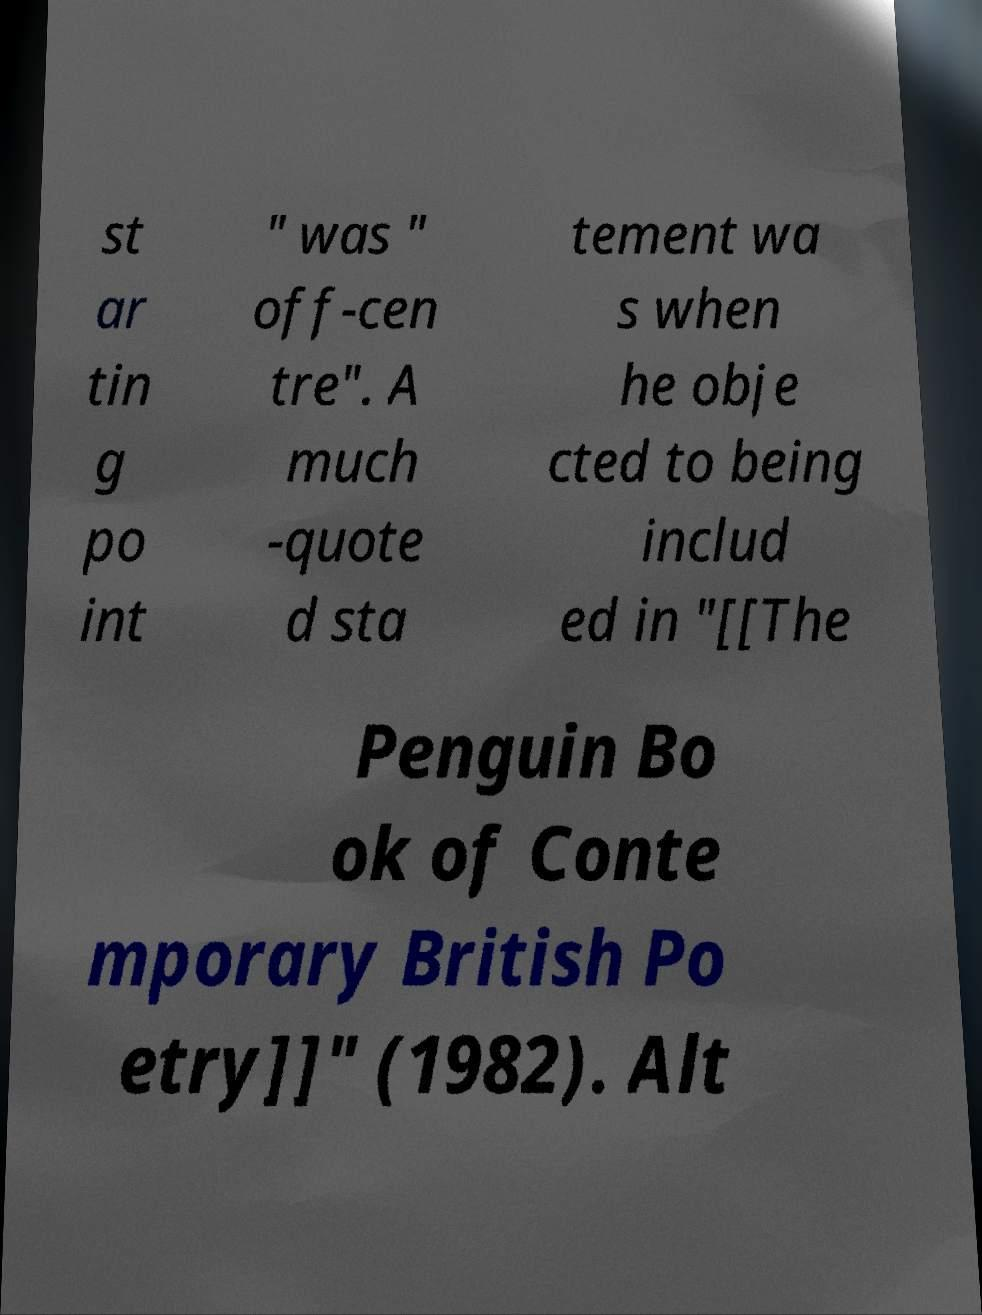Please identify and transcribe the text found in this image. st ar tin g po int " was " off-cen tre". A much -quote d sta tement wa s when he obje cted to being includ ed in "[[The Penguin Bo ok of Conte mporary British Po etry]]" (1982). Alt 